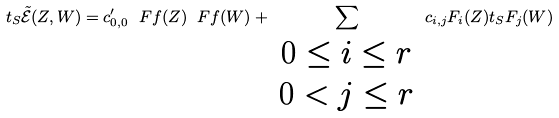Convert formula to latex. <formula><loc_0><loc_0><loc_500><loc_500>t _ { S } \tilde { \mathcal { E } } ( Z , W ) = c _ { 0 , 0 } ^ { \prime } \ F f ( Z ) \ F f ( W ) + \sum _ { \begin{array} { c } 0 \leq i \leq r \\ 0 < j \leq r \end{array} } c _ { i , j } F _ { i } ( Z ) t _ { S } F _ { j } ( W )</formula> 